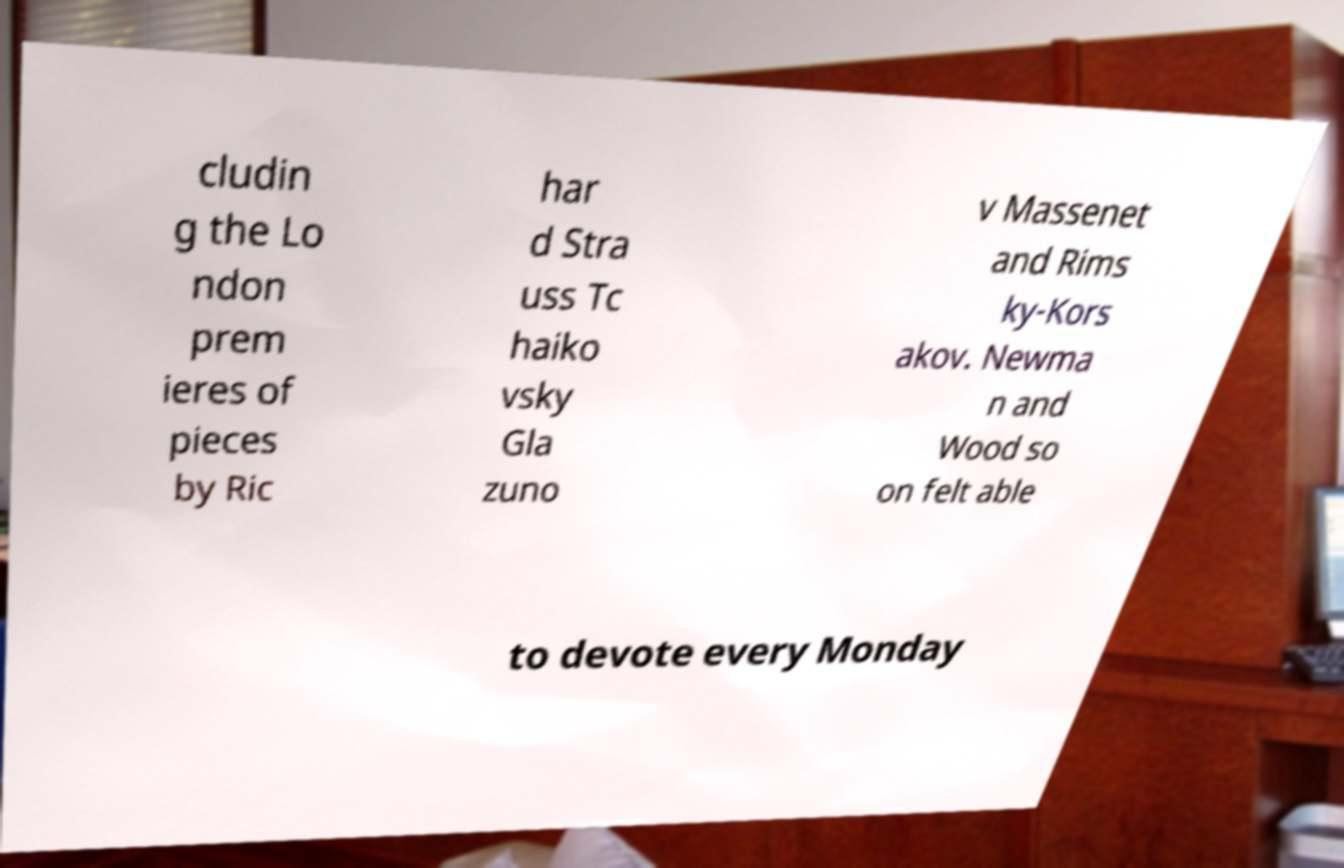What messages or text are displayed in this image? I need them in a readable, typed format. cludin g the Lo ndon prem ieres of pieces by Ric har d Stra uss Tc haiko vsky Gla zuno v Massenet and Rims ky-Kors akov. Newma n and Wood so on felt able to devote every Monday 